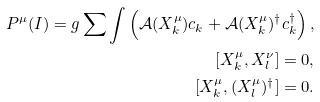<formula> <loc_0><loc_0><loc_500><loc_500>P ^ { \mu } ( I ) = g \sum \int \left ( \mathcal { A } ( X ^ { \mu } _ { k } ) c _ { k } + \mathcal { A } ( X ^ { \mu } _ { k } ) ^ { \dagger } c ^ { \dagger } _ { k } \right ) , \\ [ X ^ { \mu } _ { k } , X ^ { \nu } _ { l } ] = 0 , \\ [ X ^ { \mu } _ { k } , ( X ^ { \mu } _ { l } ) ^ { \dagger } ] = 0 .</formula> 